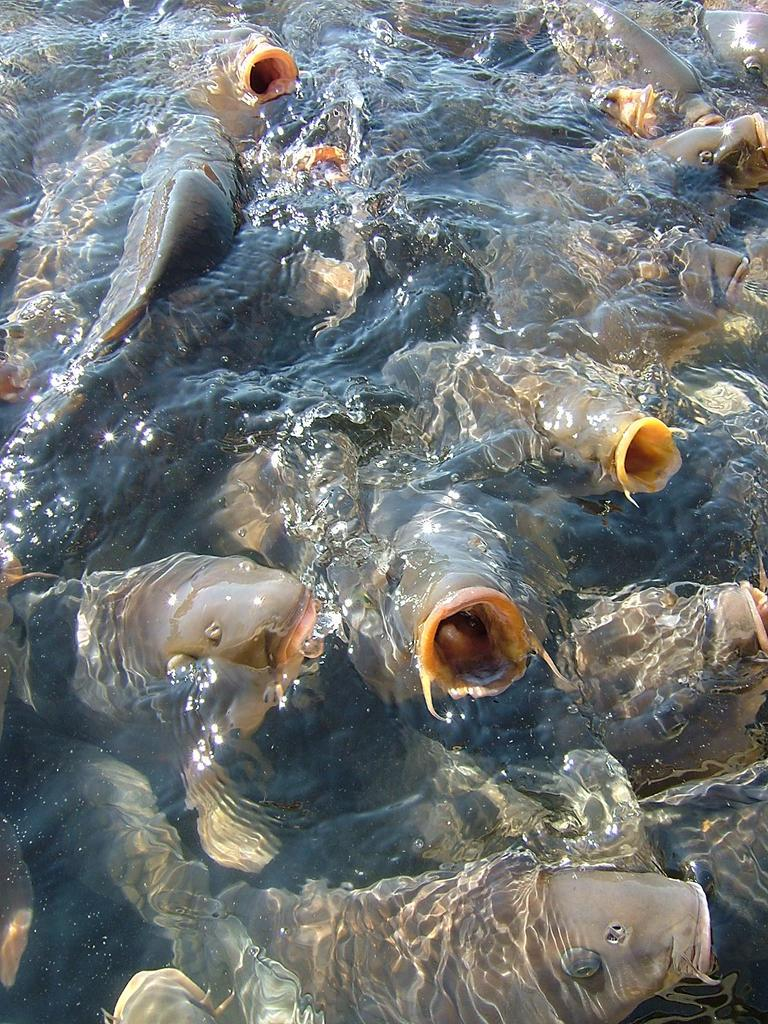What type of animals can be seen in the image? There are aquatic animals in the image. Where are the aquatic animals located? The aquatic animals are in the water. What type of hot society can be smelled in the image? There is no reference to a hot society or any smells in the image, as it features aquatic animals in the water. 